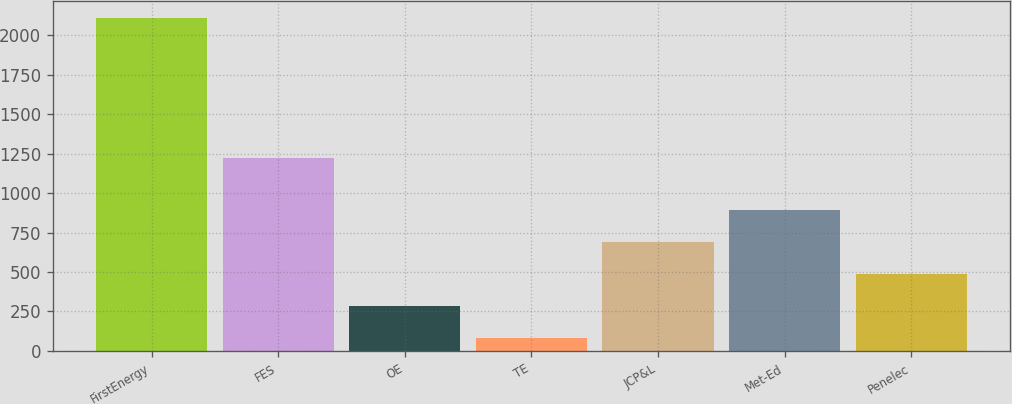Convert chart. <chart><loc_0><loc_0><loc_500><loc_500><bar_chart><fcel>FirstEnergy<fcel>FES<fcel>OE<fcel>TE<fcel>JCP&L<fcel>Met-Ed<fcel>Penelec<nl><fcel>2112<fcel>1223<fcel>285.9<fcel>83<fcel>691.7<fcel>894.6<fcel>488.8<nl></chart> 